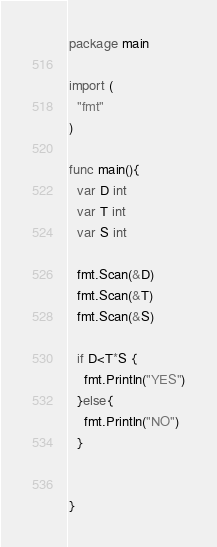<code> <loc_0><loc_0><loc_500><loc_500><_Go_>package main

import (
  "fmt"
)

func main(){
  var D int
  var T int
  var S int

  fmt.Scan(&D)
  fmt.Scan(&T)
  fmt.Scan(&S)

  if D<T*S {
    fmt.Println("YES")
  }else{
    fmt.Println("NO")
  }


}
</code> 